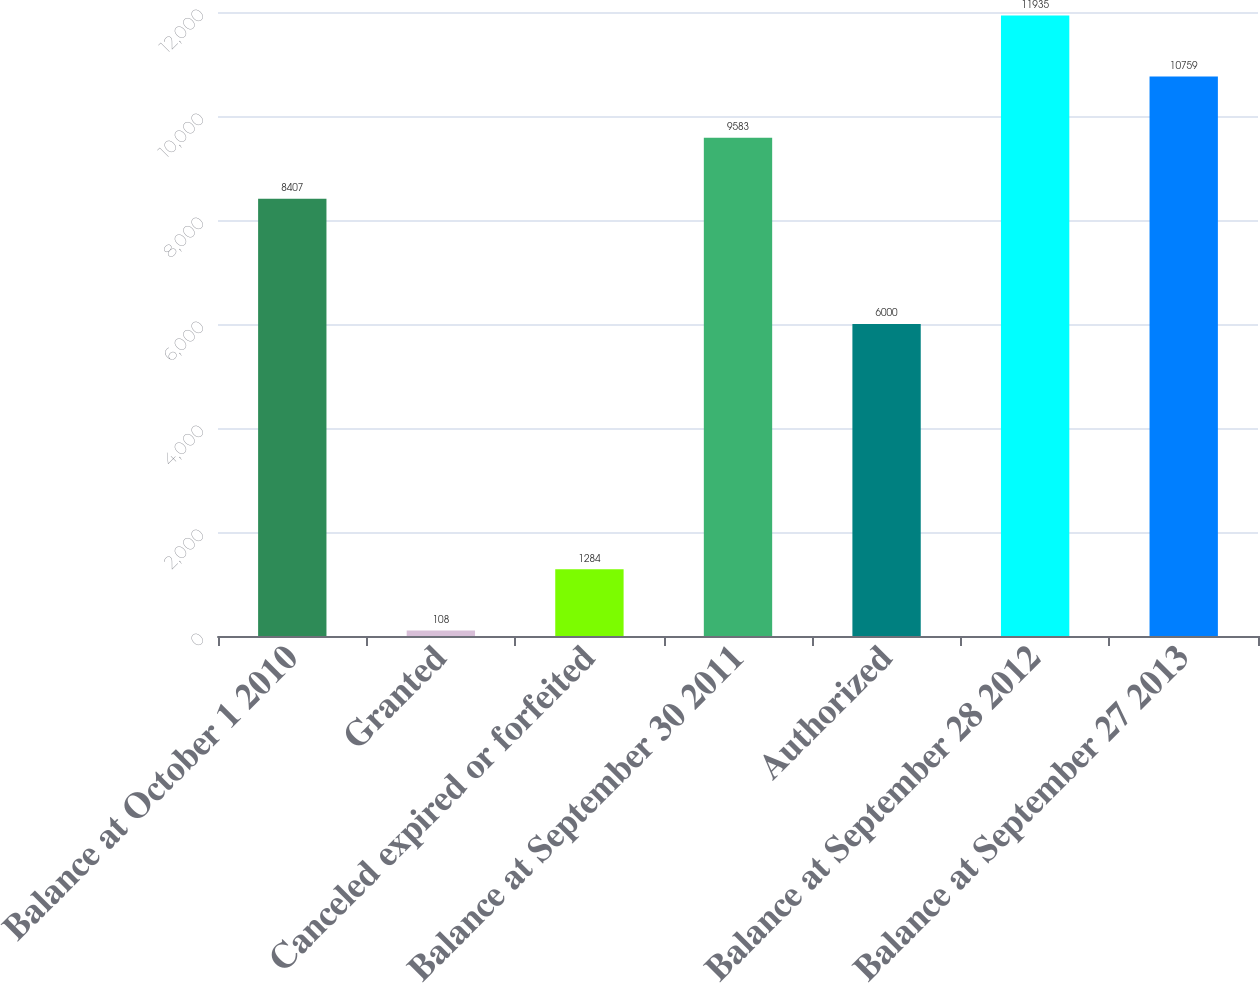Convert chart to OTSL. <chart><loc_0><loc_0><loc_500><loc_500><bar_chart><fcel>Balance at October 1 2010<fcel>Granted<fcel>Canceled expired or forfeited<fcel>Balance at September 30 2011<fcel>Authorized<fcel>Balance at September 28 2012<fcel>Balance at September 27 2013<nl><fcel>8407<fcel>108<fcel>1284<fcel>9583<fcel>6000<fcel>11935<fcel>10759<nl></chart> 